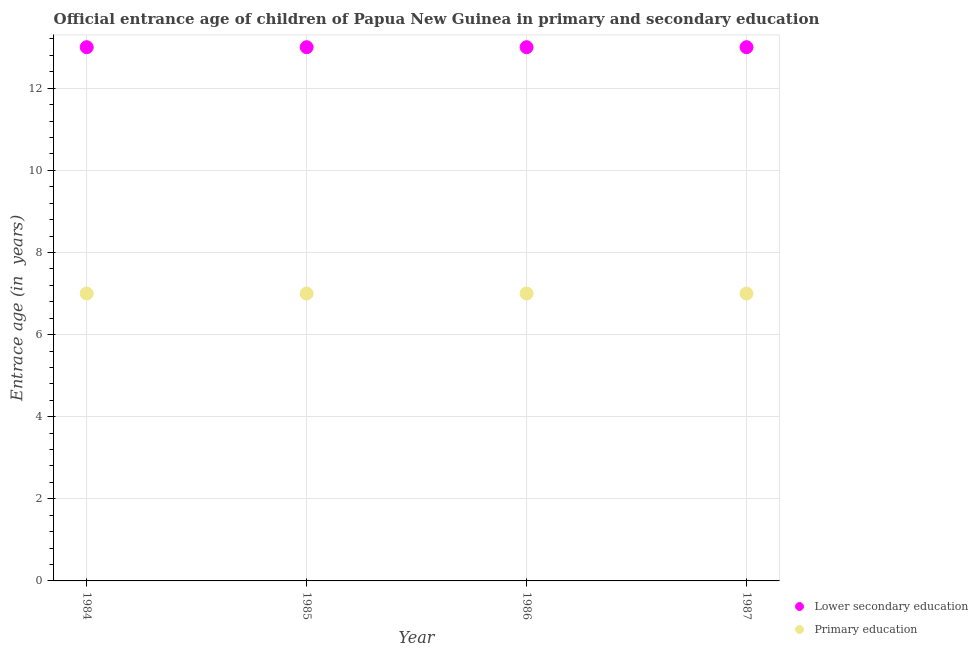How many different coloured dotlines are there?
Keep it short and to the point. 2. Is the number of dotlines equal to the number of legend labels?
Your answer should be very brief. Yes. What is the entrance age of chiildren in primary education in 1984?
Your response must be concise. 7. Across all years, what is the maximum entrance age of chiildren in primary education?
Your answer should be very brief. 7. Across all years, what is the minimum entrance age of children in lower secondary education?
Offer a very short reply. 13. In which year was the entrance age of children in lower secondary education maximum?
Offer a terse response. 1984. What is the total entrance age of chiildren in primary education in the graph?
Ensure brevity in your answer.  28. What is the difference between the entrance age of children in lower secondary education in 1987 and the entrance age of chiildren in primary education in 1984?
Make the answer very short. 6. What is the average entrance age of children in lower secondary education per year?
Give a very brief answer. 13. In the year 1984, what is the difference between the entrance age of chiildren in primary education and entrance age of children in lower secondary education?
Your response must be concise. -6. What is the ratio of the entrance age of children in lower secondary education in 1985 to that in 1986?
Keep it short and to the point. 1. Is the difference between the entrance age of children in lower secondary education in 1986 and 1987 greater than the difference between the entrance age of chiildren in primary education in 1986 and 1987?
Your response must be concise. No. Is the sum of the entrance age of children in lower secondary education in 1986 and 1987 greater than the maximum entrance age of chiildren in primary education across all years?
Offer a terse response. Yes. Does the entrance age of chiildren in primary education monotonically increase over the years?
Offer a terse response. No. Is the entrance age of chiildren in primary education strictly less than the entrance age of children in lower secondary education over the years?
Keep it short and to the point. Yes. How many dotlines are there?
Your answer should be compact. 2. Where does the legend appear in the graph?
Keep it short and to the point. Bottom right. What is the title of the graph?
Give a very brief answer. Official entrance age of children of Papua New Guinea in primary and secondary education. What is the label or title of the X-axis?
Keep it short and to the point. Year. What is the label or title of the Y-axis?
Offer a terse response. Entrace age (in  years). What is the Entrace age (in  years) of Lower secondary education in 1984?
Your answer should be very brief. 13. What is the Entrace age (in  years) in Lower secondary education in 1985?
Your answer should be compact. 13. What is the Entrace age (in  years) in Primary education in 1985?
Ensure brevity in your answer.  7. What is the Entrace age (in  years) of Lower secondary education in 1987?
Your answer should be very brief. 13. What is the Entrace age (in  years) in Primary education in 1987?
Your response must be concise. 7. Across all years, what is the maximum Entrace age (in  years) in Primary education?
Offer a terse response. 7. Across all years, what is the minimum Entrace age (in  years) of Primary education?
Offer a terse response. 7. What is the total Entrace age (in  years) in Lower secondary education in the graph?
Offer a terse response. 52. What is the total Entrace age (in  years) in Primary education in the graph?
Your answer should be compact. 28. What is the difference between the Entrace age (in  years) of Primary education in 1984 and that in 1985?
Offer a very short reply. 0. What is the difference between the Entrace age (in  years) of Lower secondary education in 1984 and that in 1986?
Your answer should be compact. 0. What is the difference between the Entrace age (in  years) in Lower secondary education in 1984 and that in 1987?
Make the answer very short. 0. What is the difference between the Entrace age (in  years) of Lower secondary education in 1985 and that in 1987?
Your response must be concise. 0. What is the difference between the Entrace age (in  years) of Primary education in 1985 and that in 1987?
Offer a very short reply. 0. What is the difference between the Entrace age (in  years) of Primary education in 1986 and that in 1987?
Ensure brevity in your answer.  0. What is the difference between the Entrace age (in  years) of Lower secondary education in 1984 and the Entrace age (in  years) of Primary education in 1985?
Offer a terse response. 6. What is the difference between the Entrace age (in  years) in Lower secondary education in 1984 and the Entrace age (in  years) in Primary education in 1986?
Your response must be concise. 6. What is the difference between the Entrace age (in  years) of Lower secondary education in 1984 and the Entrace age (in  years) of Primary education in 1987?
Your answer should be very brief. 6. What is the difference between the Entrace age (in  years) in Lower secondary education in 1985 and the Entrace age (in  years) in Primary education in 1987?
Your answer should be compact. 6. What is the difference between the Entrace age (in  years) of Lower secondary education in 1986 and the Entrace age (in  years) of Primary education in 1987?
Your response must be concise. 6. In the year 1985, what is the difference between the Entrace age (in  years) of Lower secondary education and Entrace age (in  years) of Primary education?
Your answer should be very brief. 6. What is the ratio of the Entrace age (in  years) in Lower secondary education in 1984 to that in 1985?
Your response must be concise. 1. What is the ratio of the Entrace age (in  years) in Lower secondary education in 1984 to that in 1986?
Ensure brevity in your answer.  1. What is the ratio of the Entrace age (in  years) in Primary education in 1984 to that in 1986?
Provide a short and direct response. 1. What is the ratio of the Entrace age (in  years) of Lower secondary education in 1984 to that in 1987?
Offer a very short reply. 1. What is the ratio of the Entrace age (in  years) of Lower secondary education in 1985 to that in 1986?
Provide a succinct answer. 1. What is the ratio of the Entrace age (in  years) in Primary education in 1985 to that in 1987?
Your answer should be very brief. 1. What is the ratio of the Entrace age (in  years) in Lower secondary education in 1986 to that in 1987?
Provide a succinct answer. 1. What is the ratio of the Entrace age (in  years) of Primary education in 1986 to that in 1987?
Make the answer very short. 1. What is the difference between the highest and the lowest Entrace age (in  years) in Lower secondary education?
Provide a short and direct response. 0. 